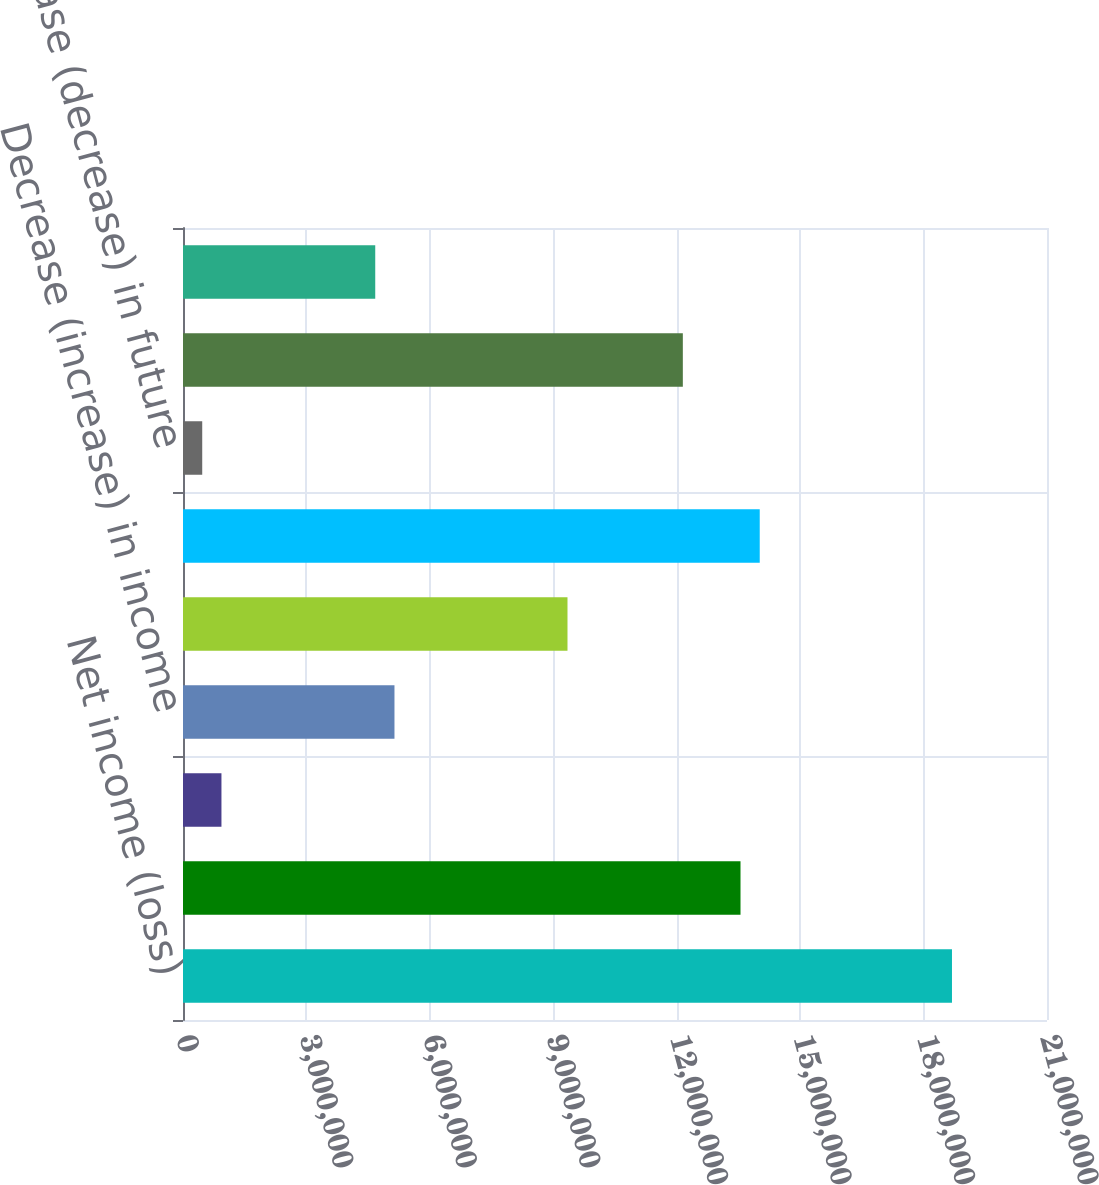<chart> <loc_0><loc_0><loc_500><loc_500><bar_chart><fcel>Net income (loss)<fcel>Decrease (increase) in<fcel>Decrease (increase) in funds<fcel>Decrease (increase) in income<fcel>Decrease (increase) in prepaid<fcel>Increase (decrease) in reserve<fcel>Increase (decrease) in future<fcel>Increase (decrease) in<fcel>Increase (decrease) in other<nl><fcel>1.86904e+07<fcel>1.35505e+07<fcel>934563<fcel>5.13989e+06<fcel>9.34522e+06<fcel>1.40178e+07<fcel>467305<fcel>1.21488e+07<fcel>4.67263e+06<nl></chart> 